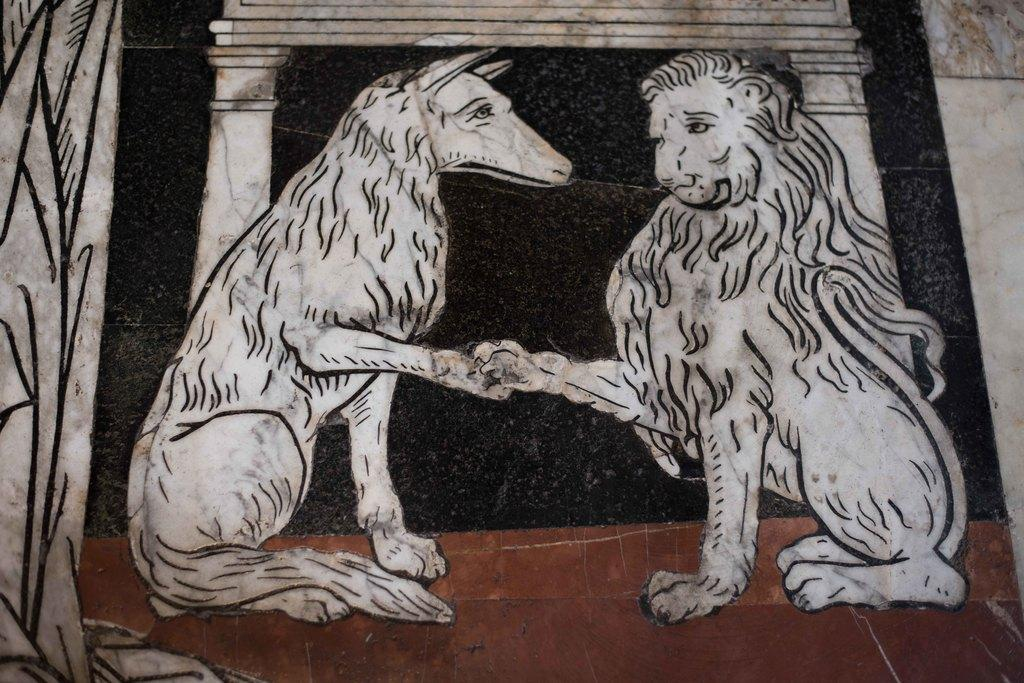What type of animal is depicted in the sketch in the image? There is a sketch of a lion in the image. What other animal can be seen in the image? There is an animal that resembles a dog in the image. What colors are used in the background of the image? The background of the image is in white, black, and brown colors. What might the background represent? The background might be a wall. What type of prison is depicted in the image? There is no prison depicted in the image; it features a sketch of a lion and an animal that resembles a dog. What type of prose can be seen in the image? There is no prose present in the image; it is a sketch of a lion and an animal that resembles a dog with a background. 